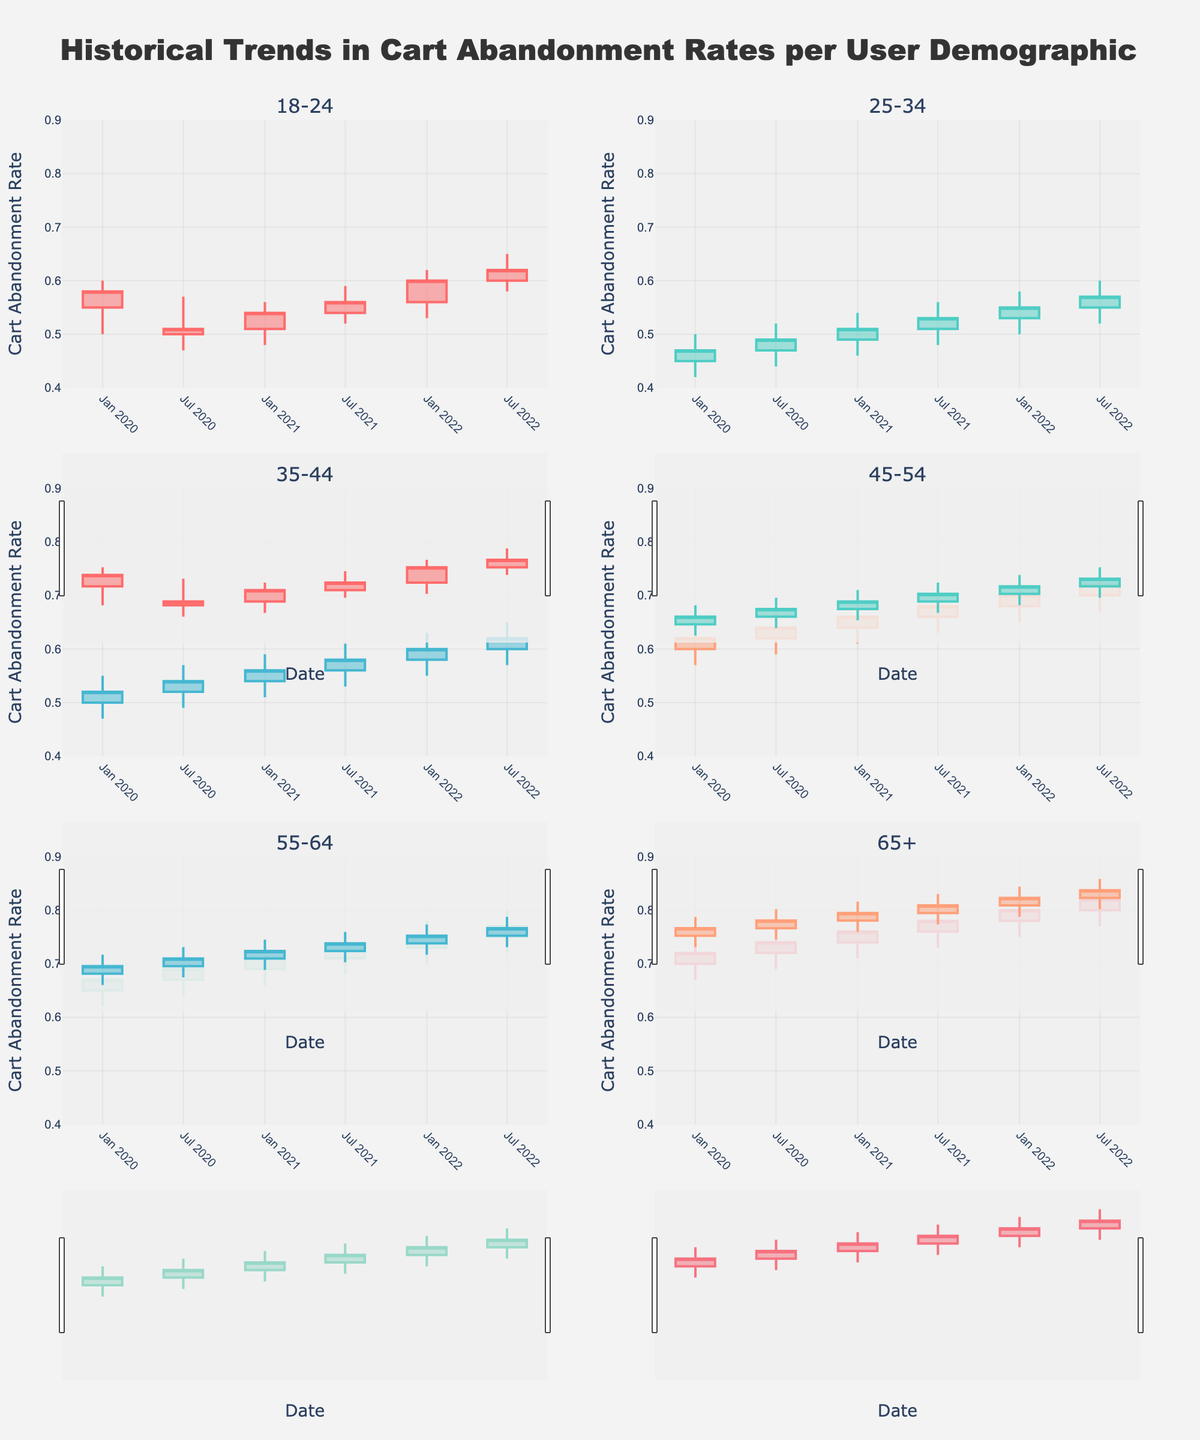What is the title of the figure? The title is usually at the top of the figure and provides a summary of what the figure represents.
Answer: Historical Trends in Cart Abandonment Rates per User Demographic How many user demographics are shown in the figure? By looking at the subplot titles, you can count the different demographics presented.
Answer: Six Which demographic has the highest cart abandonment rate in July 2022? Review each candlestick plot for July 2022 and compare the closing values. The highest closing value indicates the highest cart abandonment rate.
Answer: 65+ How does the cart abandonment rate for users aged 18-24 change from January 2020 to July 2022? Observe the candlestick plots for the 18-24 demographic from January 2020 to July 2022, looking at the closing values over time.
Answer: It increased from 0.58 to 0.62 Which age group shows the most significant increase in cart abandonment rates from January 2020 to January 2022? Compare the closing values from January 2020 and January 2022 across all demographics to identify the one with the largest difference.
Answer: 65+ What is the range of cart abandonment rates for the 45-54 age group in July 2021? Locate the candlestick for the 45-54 demographic in July 2021 and calculate the range by subtracting the low value from the high value (0.71 - 0.63).
Answer: 0.08 Which demographic has the narrowest range of cart abandonment rates in January 2022? Compare the range (high - low) for January 2022 across all demographics.
Answer: 25-34 What trend is observed in the cart abandonment rates for users aged 35-44 from January 2020 to July 2022? Look at the closing values from each candlestick for the 35-44 demographic. Note if the values generally increase, decrease, or remain stable.
Answer: Increasing trend Is the cart abandonment rate for the demographic aged 25-34 higher or lower than the 18-24 group in January 2021? Examine the closing values for both demographics in January 2021 and compare them.
Answer: Lower What is the middle value of the cart abandonment rates for the 55-64 age group in January 2021? In a candlestick plot, the closing value can represent the middle value of the range for the specified period since it is the final value of that period.
Answer: 0.71 